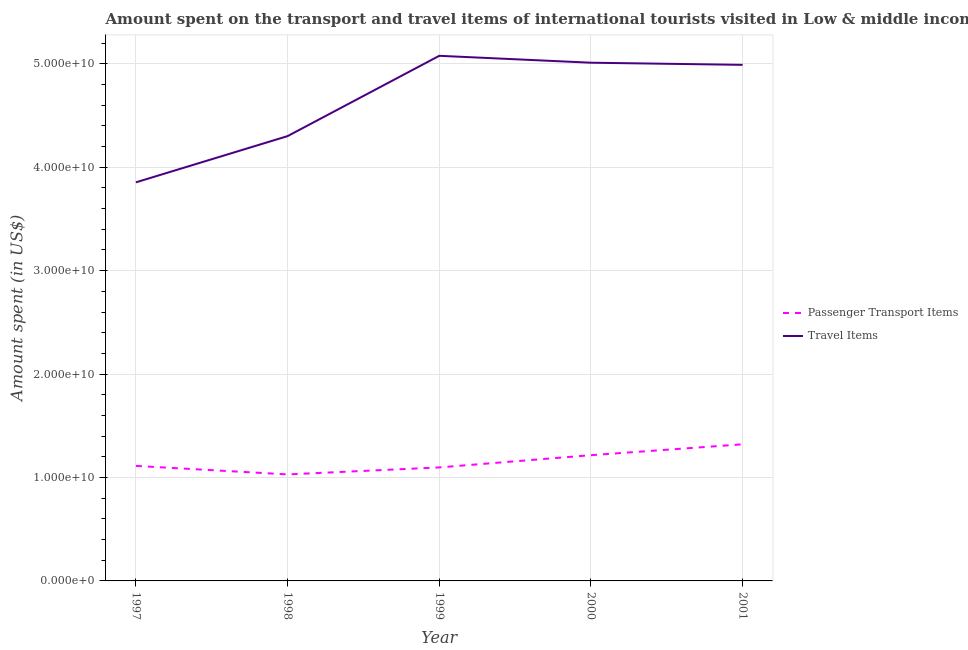How many different coloured lines are there?
Give a very brief answer. 2. Does the line corresponding to amount spent on passenger transport items intersect with the line corresponding to amount spent in travel items?
Provide a short and direct response. No. What is the amount spent on passenger transport items in 2000?
Your answer should be compact. 1.22e+1. Across all years, what is the maximum amount spent on passenger transport items?
Give a very brief answer. 1.32e+1. Across all years, what is the minimum amount spent in travel items?
Keep it short and to the point. 3.85e+1. What is the total amount spent on passenger transport items in the graph?
Provide a short and direct response. 5.78e+1. What is the difference between the amount spent on passenger transport items in 2000 and that in 2001?
Offer a terse response. -1.05e+09. What is the difference between the amount spent in travel items in 2000 and the amount spent on passenger transport items in 2001?
Offer a terse response. 3.69e+1. What is the average amount spent on passenger transport items per year?
Offer a very short reply. 1.16e+1. In the year 2001, what is the difference between the amount spent in travel items and amount spent on passenger transport items?
Your answer should be very brief. 3.67e+1. In how many years, is the amount spent in travel items greater than 38000000000 US$?
Offer a very short reply. 5. What is the ratio of the amount spent in travel items in 1997 to that in 2000?
Provide a short and direct response. 0.77. Is the amount spent on passenger transport items in 1997 less than that in 2000?
Provide a succinct answer. Yes. Is the difference between the amount spent on passenger transport items in 1997 and 1999 greater than the difference between the amount spent in travel items in 1997 and 1999?
Make the answer very short. Yes. What is the difference between the highest and the second highest amount spent on passenger transport items?
Give a very brief answer. 1.05e+09. What is the difference between the highest and the lowest amount spent in travel items?
Give a very brief answer. 1.22e+1. In how many years, is the amount spent in travel items greater than the average amount spent in travel items taken over all years?
Make the answer very short. 3. Is the sum of the amount spent in travel items in 2000 and 2001 greater than the maximum amount spent on passenger transport items across all years?
Your response must be concise. Yes. Does the amount spent in travel items monotonically increase over the years?
Provide a short and direct response. No. Is the amount spent in travel items strictly greater than the amount spent on passenger transport items over the years?
Make the answer very short. Yes. Is the amount spent on passenger transport items strictly less than the amount spent in travel items over the years?
Offer a terse response. Yes. What is the difference between two consecutive major ticks on the Y-axis?
Provide a succinct answer. 1.00e+1. Are the values on the major ticks of Y-axis written in scientific E-notation?
Offer a terse response. Yes. Where does the legend appear in the graph?
Keep it short and to the point. Center right. How many legend labels are there?
Offer a very short reply. 2. What is the title of the graph?
Your answer should be very brief. Amount spent on the transport and travel items of international tourists visited in Low & middle income. What is the label or title of the X-axis?
Your answer should be very brief. Year. What is the label or title of the Y-axis?
Offer a very short reply. Amount spent (in US$). What is the Amount spent (in US$) in Passenger Transport Items in 1997?
Provide a succinct answer. 1.11e+1. What is the Amount spent (in US$) in Travel Items in 1997?
Provide a succinct answer. 3.85e+1. What is the Amount spent (in US$) of Passenger Transport Items in 1998?
Give a very brief answer. 1.03e+1. What is the Amount spent (in US$) of Travel Items in 1998?
Give a very brief answer. 4.30e+1. What is the Amount spent (in US$) in Passenger Transport Items in 1999?
Your response must be concise. 1.10e+1. What is the Amount spent (in US$) in Travel Items in 1999?
Your response must be concise. 5.08e+1. What is the Amount spent (in US$) in Passenger Transport Items in 2000?
Your answer should be compact. 1.22e+1. What is the Amount spent (in US$) of Travel Items in 2000?
Offer a very short reply. 5.01e+1. What is the Amount spent (in US$) of Passenger Transport Items in 2001?
Your answer should be compact. 1.32e+1. What is the Amount spent (in US$) of Travel Items in 2001?
Provide a succinct answer. 4.99e+1. Across all years, what is the maximum Amount spent (in US$) in Passenger Transport Items?
Your answer should be compact. 1.32e+1. Across all years, what is the maximum Amount spent (in US$) of Travel Items?
Provide a succinct answer. 5.08e+1. Across all years, what is the minimum Amount spent (in US$) in Passenger Transport Items?
Give a very brief answer. 1.03e+1. Across all years, what is the minimum Amount spent (in US$) in Travel Items?
Your answer should be very brief. 3.85e+1. What is the total Amount spent (in US$) of Passenger Transport Items in the graph?
Offer a very short reply. 5.78e+1. What is the total Amount spent (in US$) of Travel Items in the graph?
Ensure brevity in your answer.  2.32e+11. What is the difference between the Amount spent (in US$) in Passenger Transport Items in 1997 and that in 1998?
Your response must be concise. 8.24e+08. What is the difference between the Amount spent (in US$) of Travel Items in 1997 and that in 1998?
Give a very brief answer. -4.47e+09. What is the difference between the Amount spent (in US$) of Passenger Transport Items in 1997 and that in 1999?
Your response must be concise. 1.47e+08. What is the difference between the Amount spent (in US$) in Travel Items in 1997 and that in 1999?
Your response must be concise. -1.22e+1. What is the difference between the Amount spent (in US$) in Passenger Transport Items in 1997 and that in 2000?
Give a very brief answer. -1.04e+09. What is the difference between the Amount spent (in US$) in Travel Items in 1997 and that in 2000?
Provide a succinct answer. -1.16e+1. What is the difference between the Amount spent (in US$) in Passenger Transport Items in 1997 and that in 2001?
Keep it short and to the point. -2.09e+09. What is the difference between the Amount spent (in US$) in Travel Items in 1997 and that in 2001?
Offer a very short reply. -1.14e+1. What is the difference between the Amount spent (in US$) of Passenger Transport Items in 1998 and that in 1999?
Offer a terse response. -6.76e+08. What is the difference between the Amount spent (in US$) of Travel Items in 1998 and that in 1999?
Give a very brief answer. -7.77e+09. What is the difference between the Amount spent (in US$) of Passenger Transport Items in 1998 and that in 2000?
Ensure brevity in your answer.  -1.86e+09. What is the difference between the Amount spent (in US$) of Travel Items in 1998 and that in 2000?
Offer a terse response. -7.10e+09. What is the difference between the Amount spent (in US$) in Passenger Transport Items in 1998 and that in 2001?
Keep it short and to the point. -2.91e+09. What is the difference between the Amount spent (in US$) of Travel Items in 1998 and that in 2001?
Keep it short and to the point. -6.89e+09. What is the difference between the Amount spent (in US$) of Passenger Transport Items in 1999 and that in 2000?
Offer a very short reply. -1.18e+09. What is the difference between the Amount spent (in US$) in Travel Items in 1999 and that in 2000?
Provide a succinct answer. 6.66e+08. What is the difference between the Amount spent (in US$) of Passenger Transport Items in 1999 and that in 2001?
Give a very brief answer. -2.24e+09. What is the difference between the Amount spent (in US$) of Travel Items in 1999 and that in 2001?
Offer a very short reply. 8.75e+08. What is the difference between the Amount spent (in US$) in Passenger Transport Items in 2000 and that in 2001?
Offer a very short reply. -1.05e+09. What is the difference between the Amount spent (in US$) in Travel Items in 2000 and that in 2001?
Offer a very short reply. 2.08e+08. What is the difference between the Amount spent (in US$) in Passenger Transport Items in 1997 and the Amount spent (in US$) in Travel Items in 1998?
Give a very brief answer. -3.19e+1. What is the difference between the Amount spent (in US$) in Passenger Transport Items in 1997 and the Amount spent (in US$) in Travel Items in 1999?
Ensure brevity in your answer.  -3.96e+1. What is the difference between the Amount spent (in US$) of Passenger Transport Items in 1997 and the Amount spent (in US$) of Travel Items in 2000?
Make the answer very short. -3.90e+1. What is the difference between the Amount spent (in US$) of Passenger Transport Items in 1997 and the Amount spent (in US$) of Travel Items in 2001?
Offer a very short reply. -3.88e+1. What is the difference between the Amount spent (in US$) in Passenger Transport Items in 1998 and the Amount spent (in US$) in Travel Items in 1999?
Ensure brevity in your answer.  -4.05e+1. What is the difference between the Amount spent (in US$) in Passenger Transport Items in 1998 and the Amount spent (in US$) in Travel Items in 2000?
Your answer should be very brief. -3.98e+1. What is the difference between the Amount spent (in US$) in Passenger Transport Items in 1998 and the Amount spent (in US$) in Travel Items in 2001?
Your answer should be very brief. -3.96e+1. What is the difference between the Amount spent (in US$) in Passenger Transport Items in 1999 and the Amount spent (in US$) in Travel Items in 2000?
Make the answer very short. -3.91e+1. What is the difference between the Amount spent (in US$) in Passenger Transport Items in 1999 and the Amount spent (in US$) in Travel Items in 2001?
Your answer should be very brief. -3.89e+1. What is the difference between the Amount spent (in US$) of Passenger Transport Items in 2000 and the Amount spent (in US$) of Travel Items in 2001?
Provide a succinct answer. -3.77e+1. What is the average Amount spent (in US$) of Passenger Transport Items per year?
Your response must be concise. 1.16e+1. What is the average Amount spent (in US$) in Travel Items per year?
Your answer should be very brief. 4.65e+1. In the year 1997, what is the difference between the Amount spent (in US$) in Passenger Transport Items and Amount spent (in US$) in Travel Items?
Your answer should be compact. -2.74e+1. In the year 1998, what is the difference between the Amount spent (in US$) in Passenger Transport Items and Amount spent (in US$) in Travel Items?
Your response must be concise. -3.27e+1. In the year 1999, what is the difference between the Amount spent (in US$) of Passenger Transport Items and Amount spent (in US$) of Travel Items?
Your answer should be very brief. -3.98e+1. In the year 2000, what is the difference between the Amount spent (in US$) in Passenger Transport Items and Amount spent (in US$) in Travel Items?
Provide a short and direct response. -3.79e+1. In the year 2001, what is the difference between the Amount spent (in US$) in Passenger Transport Items and Amount spent (in US$) in Travel Items?
Your answer should be very brief. -3.67e+1. What is the ratio of the Amount spent (in US$) in Passenger Transport Items in 1997 to that in 1998?
Your response must be concise. 1.08. What is the ratio of the Amount spent (in US$) of Travel Items in 1997 to that in 1998?
Provide a succinct answer. 0.9. What is the ratio of the Amount spent (in US$) in Passenger Transport Items in 1997 to that in 1999?
Make the answer very short. 1.01. What is the ratio of the Amount spent (in US$) of Travel Items in 1997 to that in 1999?
Your answer should be compact. 0.76. What is the ratio of the Amount spent (in US$) in Passenger Transport Items in 1997 to that in 2000?
Provide a short and direct response. 0.91. What is the ratio of the Amount spent (in US$) of Travel Items in 1997 to that in 2000?
Your answer should be compact. 0.77. What is the ratio of the Amount spent (in US$) in Passenger Transport Items in 1997 to that in 2001?
Your response must be concise. 0.84. What is the ratio of the Amount spent (in US$) of Travel Items in 1997 to that in 2001?
Ensure brevity in your answer.  0.77. What is the ratio of the Amount spent (in US$) in Passenger Transport Items in 1998 to that in 1999?
Your answer should be very brief. 0.94. What is the ratio of the Amount spent (in US$) of Travel Items in 1998 to that in 1999?
Offer a terse response. 0.85. What is the ratio of the Amount spent (in US$) of Passenger Transport Items in 1998 to that in 2000?
Make the answer very short. 0.85. What is the ratio of the Amount spent (in US$) of Travel Items in 1998 to that in 2000?
Your answer should be compact. 0.86. What is the ratio of the Amount spent (in US$) of Passenger Transport Items in 1998 to that in 2001?
Ensure brevity in your answer.  0.78. What is the ratio of the Amount spent (in US$) in Travel Items in 1998 to that in 2001?
Your answer should be very brief. 0.86. What is the ratio of the Amount spent (in US$) of Passenger Transport Items in 1999 to that in 2000?
Make the answer very short. 0.9. What is the ratio of the Amount spent (in US$) in Travel Items in 1999 to that in 2000?
Your response must be concise. 1.01. What is the ratio of the Amount spent (in US$) in Passenger Transport Items in 1999 to that in 2001?
Your answer should be compact. 0.83. What is the ratio of the Amount spent (in US$) in Travel Items in 1999 to that in 2001?
Your answer should be very brief. 1.02. What is the ratio of the Amount spent (in US$) in Passenger Transport Items in 2000 to that in 2001?
Make the answer very short. 0.92. What is the ratio of the Amount spent (in US$) in Travel Items in 2000 to that in 2001?
Make the answer very short. 1. What is the difference between the highest and the second highest Amount spent (in US$) of Passenger Transport Items?
Your answer should be very brief. 1.05e+09. What is the difference between the highest and the second highest Amount spent (in US$) of Travel Items?
Make the answer very short. 6.66e+08. What is the difference between the highest and the lowest Amount spent (in US$) of Passenger Transport Items?
Offer a terse response. 2.91e+09. What is the difference between the highest and the lowest Amount spent (in US$) of Travel Items?
Provide a short and direct response. 1.22e+1. 